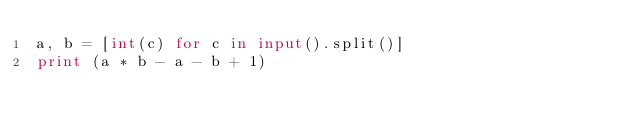Convert code to text. <code><loc_0><loc_0><loc_500><loc_500><_Python_>a, b = [int(c) for c in input().split()]
print (a * b - a - b + 1)</code> 